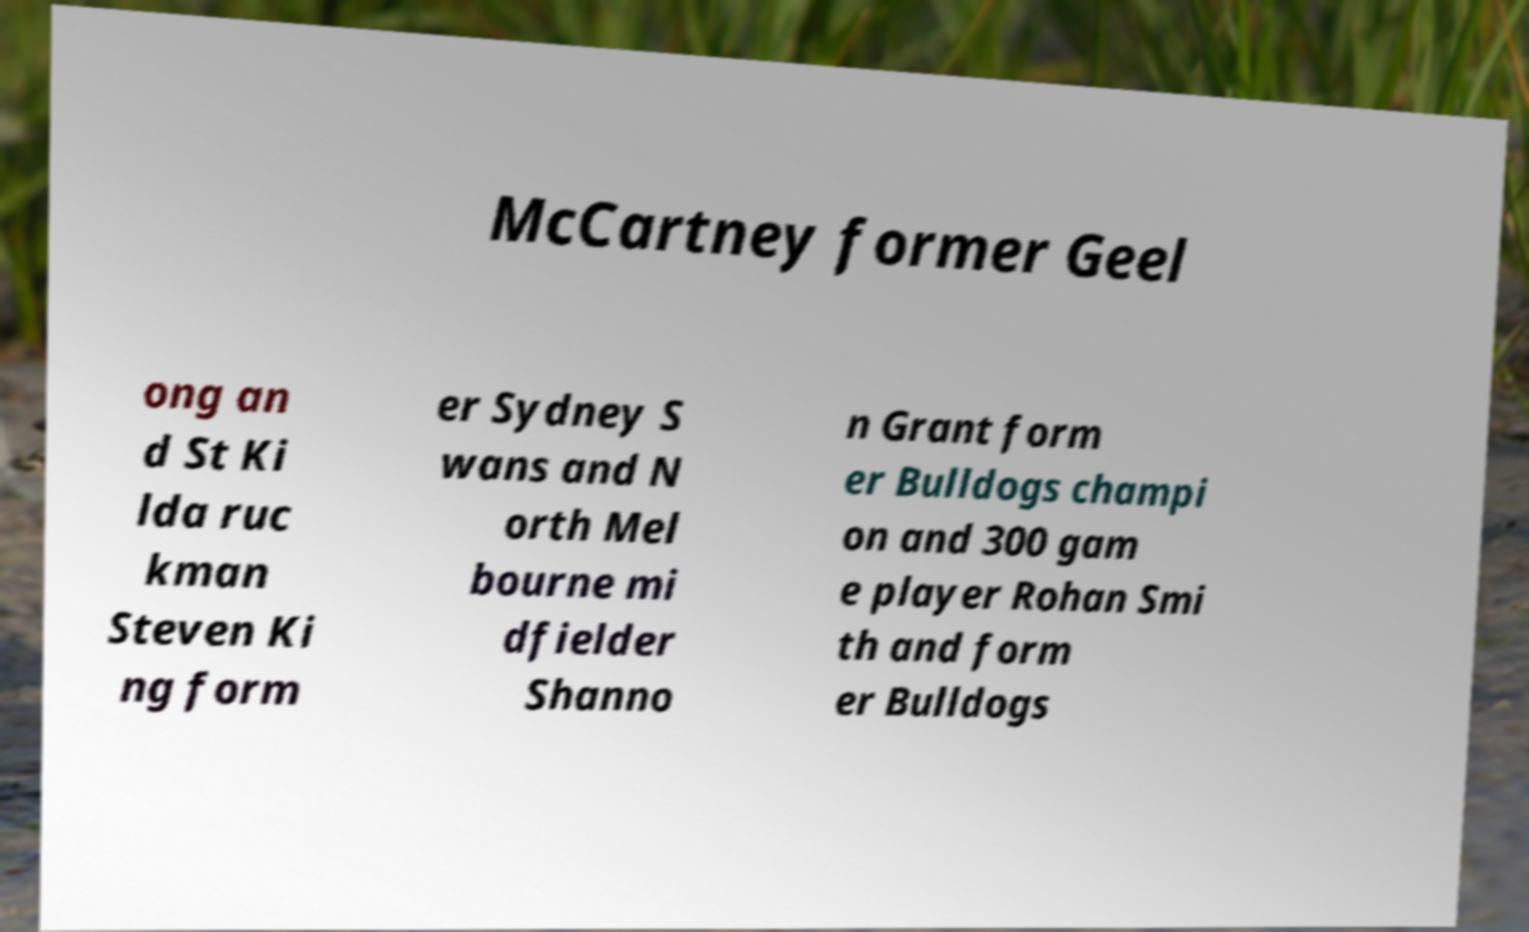Could you extract and type out the text from this image? McCartney former Geel ong an d St Ki lda ruc kman Steven Ki ng form er Sydney S wans and N orth Mel bourne mi dfielder Shanno n Grant form er Bulldogs champi on and 300 gam e player Rohan Smi th and form er Bulldogs 